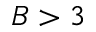Convert formula to latex. <formula><loc_0><loc_0><loc_500><loc_500>B > 3</formula> 